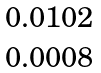<formula> <loc_0><loc_0><loc_500><loc_500>\begin{matrix} 0 . 0 1 0 2 \\ 0 . 0 0 0 8 \end{matrix}</formula> 